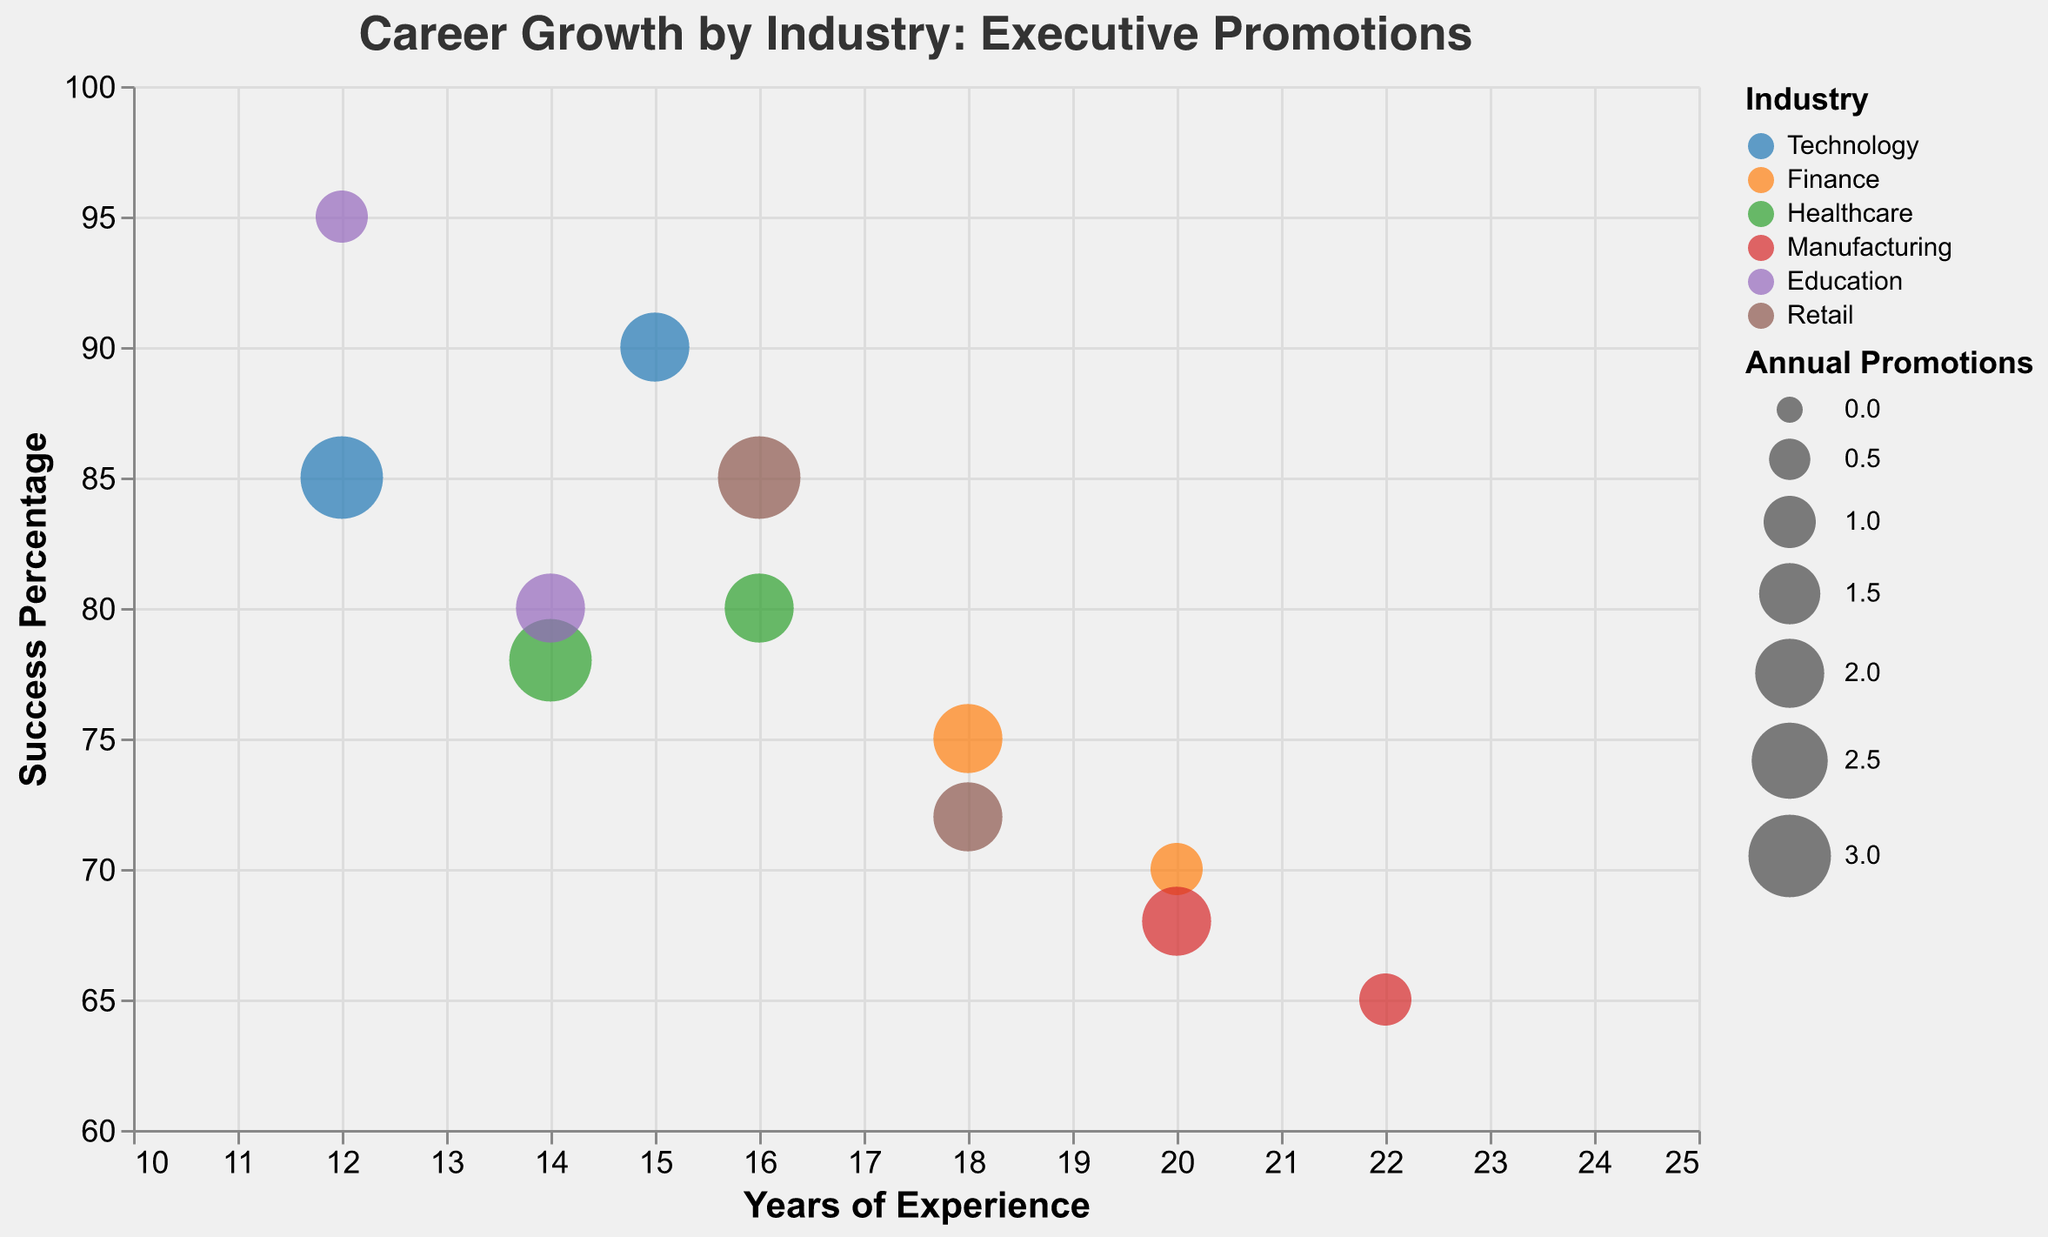What is the company with the highest success percentage? The bubble with the highest success percentage reaches 95%, represented by the role "Dean" from "Harvard University".
Answer: Harvard University Which industry has the most executive roles represented in the plot? We count the number of data points for each industry. Technology, Finance, Healthcare, Manufacturing, Education, and Retail are represented. Finance, Healthcare, and Retail have two data points each.
Answer: Finance/Healthcare/Retail Which executive role requires the most experience? By identifying the bubble farthest to the right, we see "Chief Operations Officer" at Toyota with 22 years of experience.
Answer: Chief Operations Officer How many bubbles are shown in the figure? Counting all bubbles representing each executive role and company leads to 12 bubbles.
Answer: 12 What is the industry represented by the bubble with the largest size? The size of the bubbles is determined by the annual promotions, with the largest referring to a value of 3. These largest bubbles belong to Technology, Healthcare, and Retail industries. Specifically, Google (Technology), Pfizer (Healthcare), and Amazon (Retail) have 3 annual promotions.
Answer: Technology/Healthcare/Retail Which company in the Finance industry has the higher success percentage? Comparing bubbles in Finance: JPMorgan Chase has a success percentage of 70%, and Bank of America has 75%.
Answer: Bank of America What is the average success percentage in the Education industry? Education bubbles are "Dean" from Harvard with 95% and "Provost" from Stanford with 80%. Averaging these gives (95 + 80) / 2 = 87.5%.
Answer: 87.5% Which executive role in Technology has more annual promotions? Apple (CTO) has 2 annual promotions, and Google (VP of Engineering) has 3.
Answer: VP of Engineering Which location has the highest cumulative success percentage across companies present? Looking at locations: New York hosts 2 companies with 70% and 78%, totaling 148%. All other locations host one company or have a lower cumulative percentage.
Answer: New York 